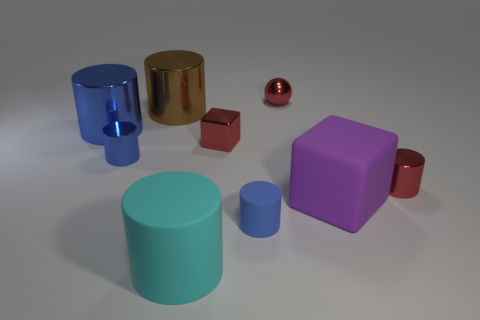There is a tiny blue object in front of the tiny blue metal object; what is it made of?
Provide a succinct answer. Rubber. How many things are purple metallic cylinders or small metal cylinders left of the purple rubber object?
Your answer should be compact. 1. What is the shape of the other blue thing that is the same size as the blue rubber thing?
Your response must be concise. Cylinder. How many big matte cylinders have the same color as the metallic ball?
Give a very brief answer. 0. Is the material of the block that is left of the small red sphere the same as the big blue cylinder?
Give a very brief answer. Yes. The big blue metallic thing is what shape?
Offer a terse response. Cylinder. How many blue objects are either large cubes or small cylinders?
Keep it short and to the point. 2. What number of other things are there of the same material as the large cube
Keep it short and to the point. 2. There is a tiny blue object that is on the left side of the large cyan matte cylinder; is it the same shape as the purple thing?
Your response must be concise. No. Is there a large blue rubber thing?
Your answer should be very brief. No. 